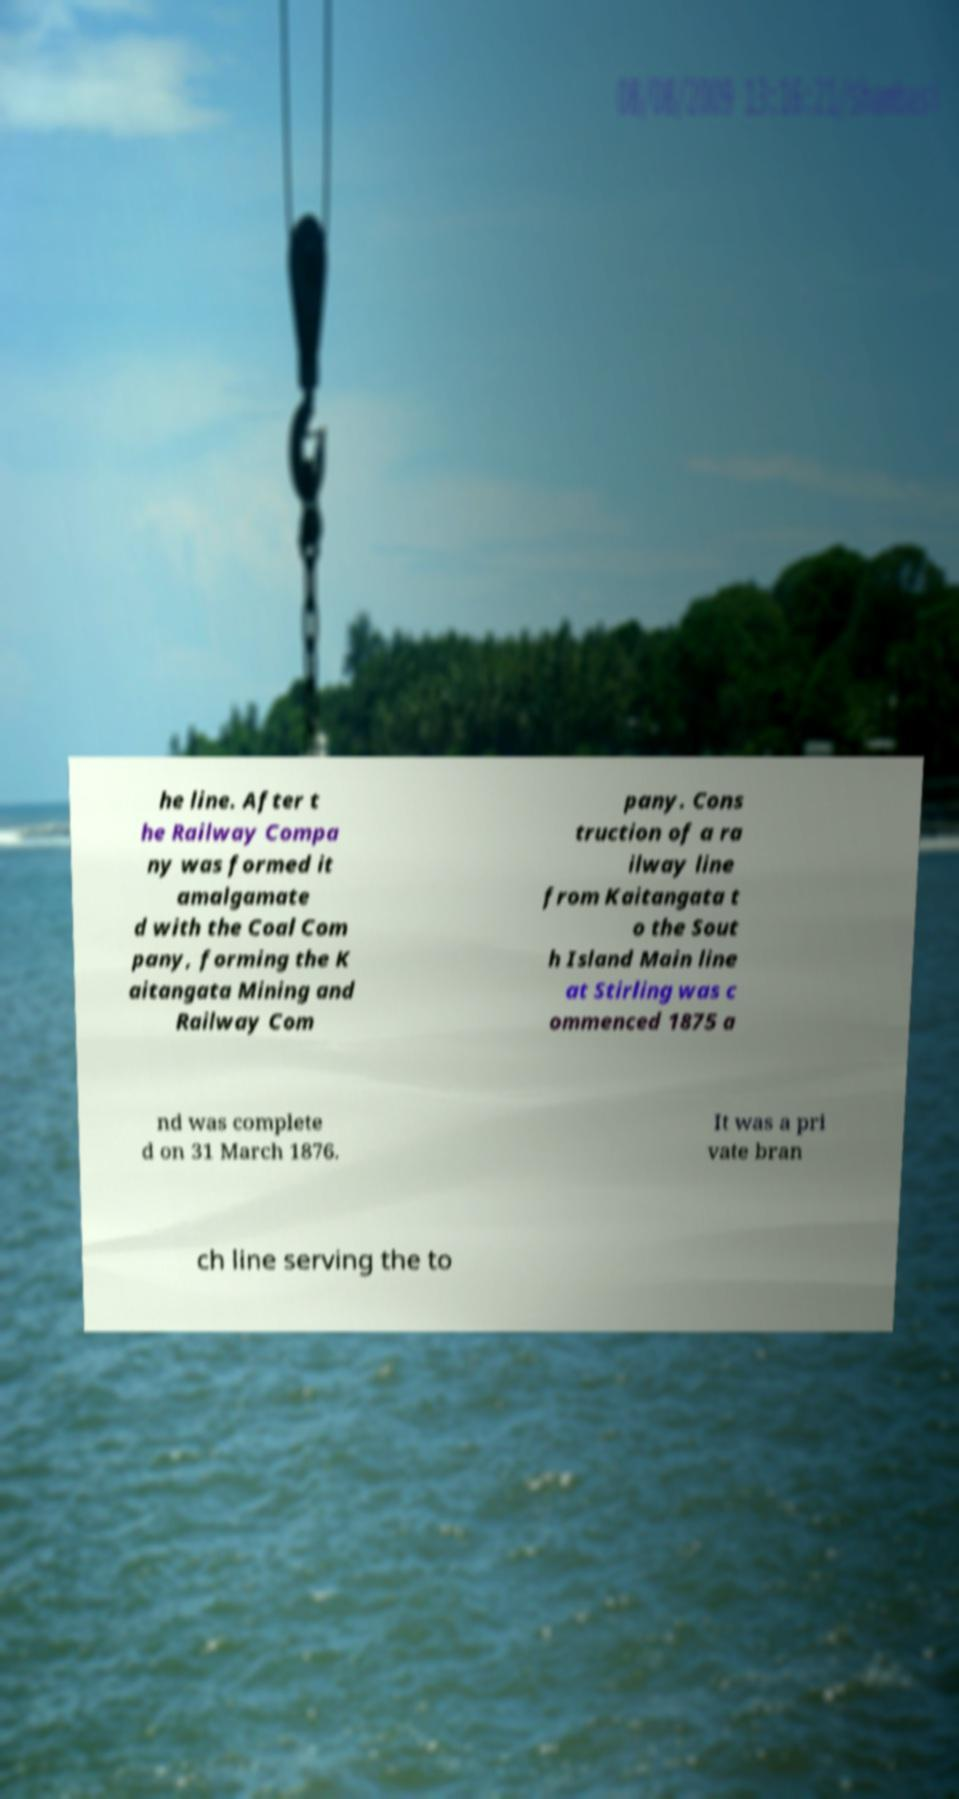For documentation purposes, I need the text within this image transcribed. Could you provide that? he line. After t he Railway Compa ny was formed it amalgamate d with the Coal Com pany, forming the K aitangata Mining and Railway Com pany. Cons truction of a ra ilway line from Kaitangata t o the Sout h Island Main line at Stirling was c ommenced 1875 a nd was complete d on 31 March 1876. It was a pri vate bran ch line serving the to 